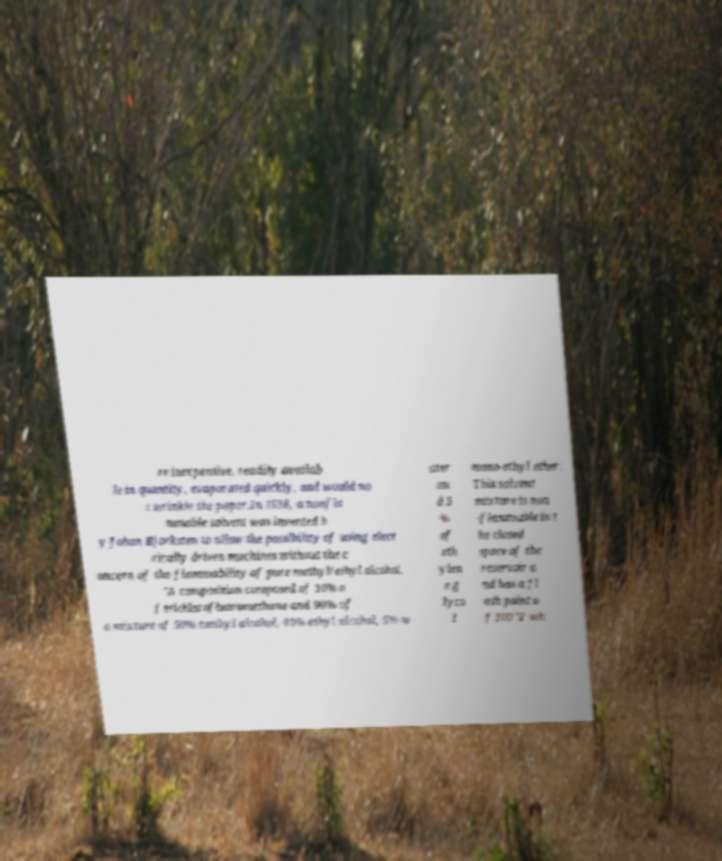Can you accurately transcribe the text from the provided image for me? re inexpensive, readily availab le in quantity, evaporated quickly, and would no t wrinkle the paper.In 1938, a nonfla mmable solvent was invented b y Johan Bjorksten to allow the possibility of using elect rically driven machines without the c oncern of the flammability of pure methyl/ethyl alcohol. "A composition composed of 10% o f trichlorofluoromethane and 90% of a mixture of 50% methyl alcohol, 40% ethyl alcohol, 5% w ater an d 5 % of eth ylen e g lyco l mono-ethyl ether. This solvent mixture is non -flammable in t he closed space of the reservoir a nd has a fl ash point o f 100 °F wh 